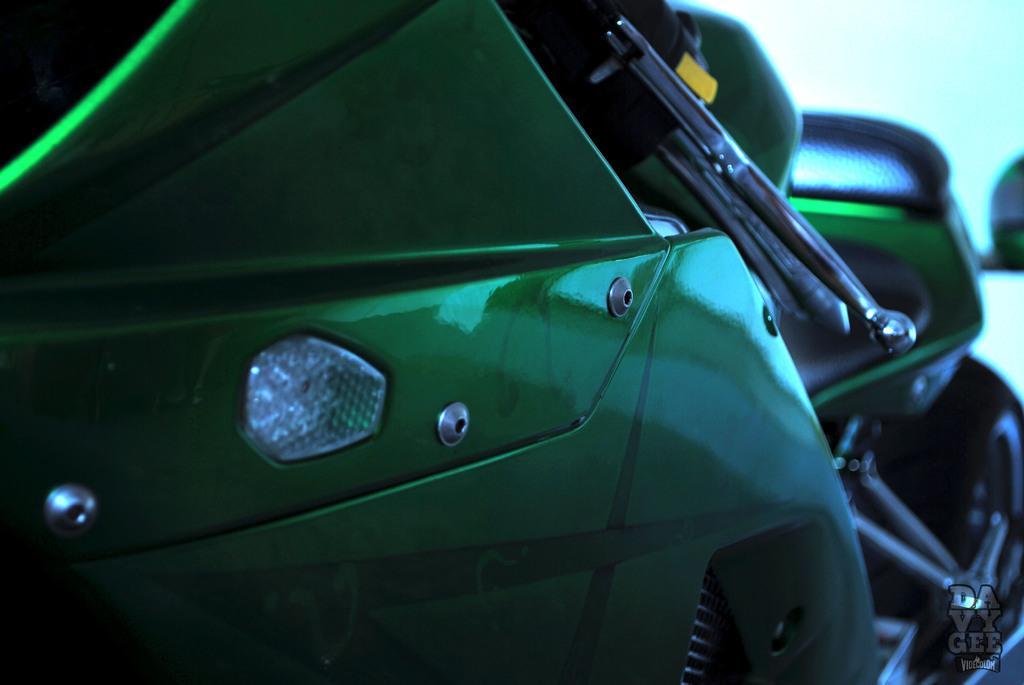Can you describe this image briefly? In this image we can see a close view of a motorbike. 